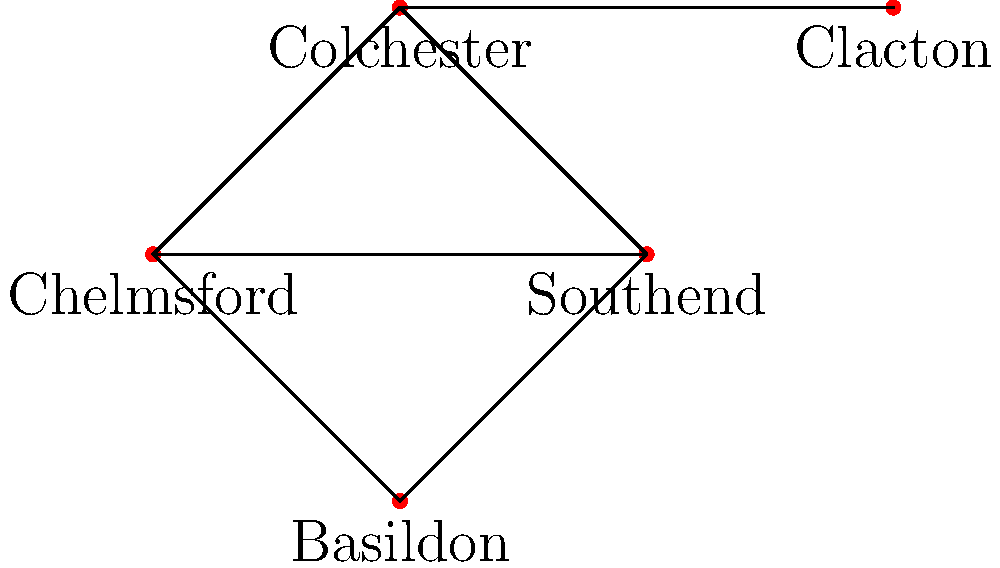In the simplified road network of Essex shown above, which town acts as the central hub, connecting to the most other towns directly? To determine which town acts as the central hub in this simplified Essex road network, we need to count the direct connections for each town:

1. Chelmsford: Connected directly to Colchester, Southend, and Basildon (3 connections)
2. Colchester: Connected directly to Chelmsford, Clacton, and Southend (3 connections)
3. Southend: Connected directly to Chelmsford, Colchester, and Basildon (3 connections)
4. Basildon: Connected directly to Chelmsford and Southend (2 connections)
5. Clacton: Connected directly to Colchester (1 connection)

From this analysis, we can see that Chelmsford, Colchester, and Southend all have the maximum number of direct connections (3 each). However, Chelmsford's position in the network makes it the most central, as it connects to towns in all directions, effectively acting as a hub for the region.
Answer: Chelmsford 